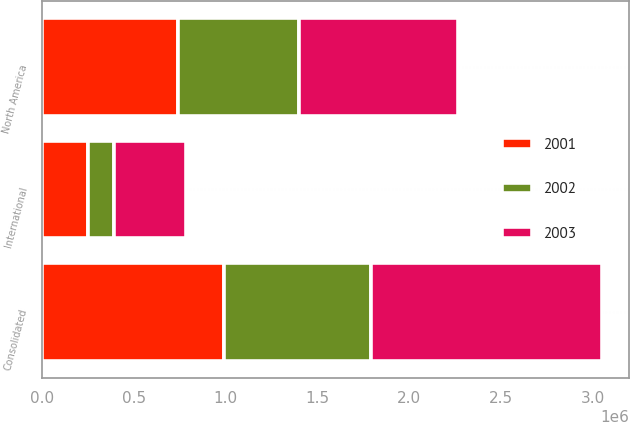<chart> <loc_0><loc_0><loc_500><loc_500><stacked_bar_chart><ecel><fcel>North America<fcel>International<fcel>Consolidated<nl><fcel>2003<fcel>866664<fcel>390504<fcel>1.25717e+06<nl><fcel>2001<fcel>740985<fcel>251633<fcel>992618<nl><fcel>2002<fcel>657229<fcel>141329<fcel>798558<nl></chart> 